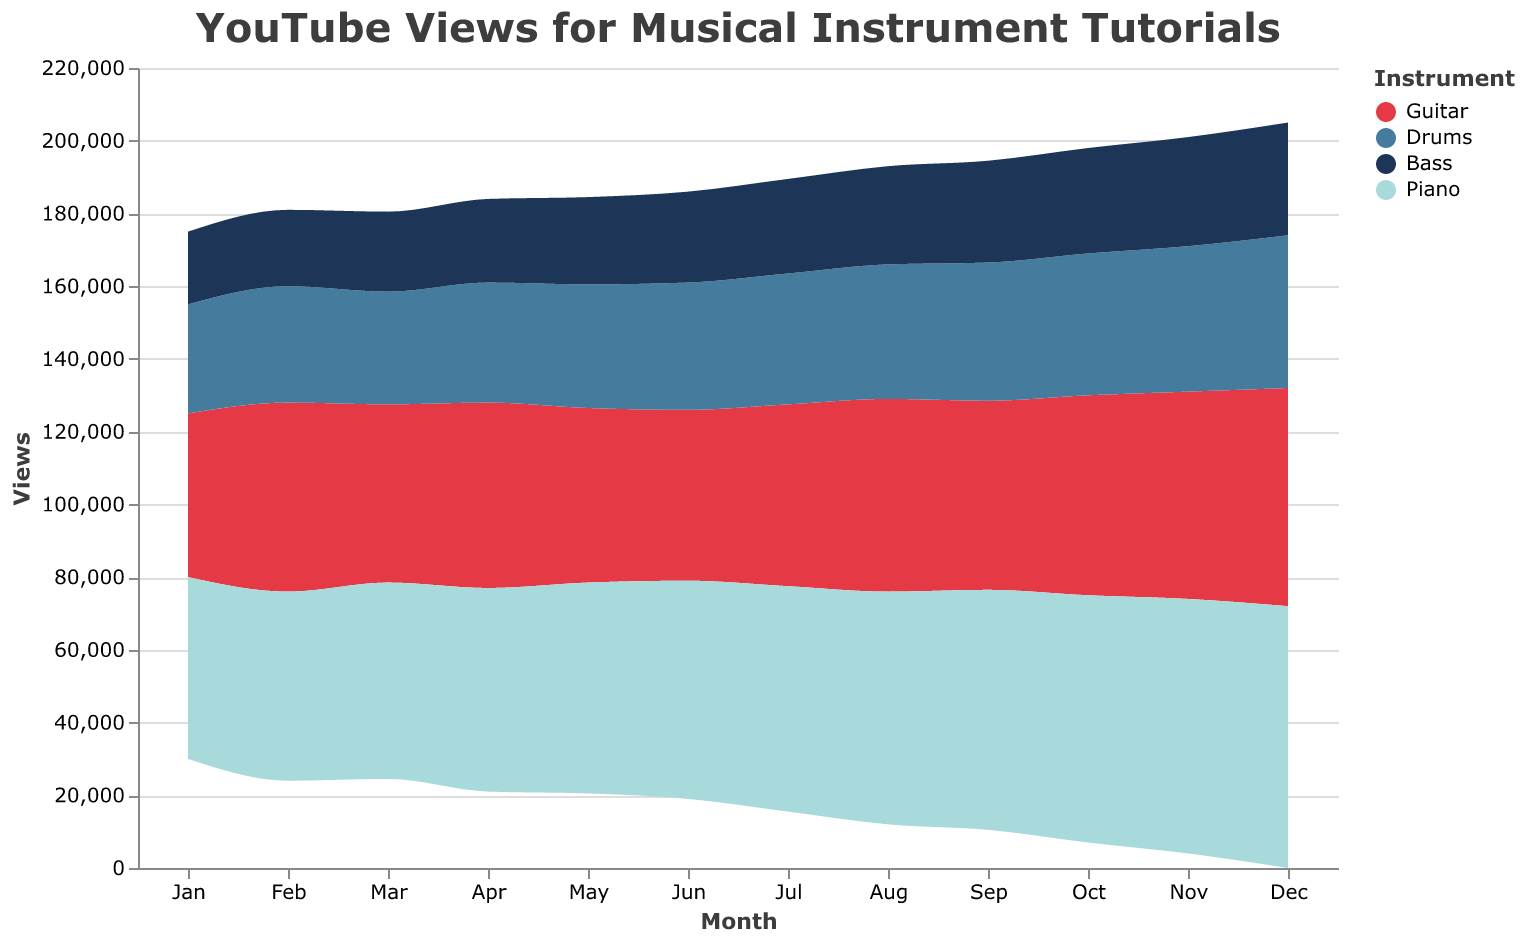What's the title of the figure? The title is usually located at the top of the figure. It provides an overview of what the chart represents. Here, it states: "YouTube Views for Musical Instrument Tutorials".
Answer: YouTube Views for Musical Instrument Tutorials What is the color used to represent Guitar in the graph? Each instrument type is represented by a distinct color. The legend indicates that Guitar is represented by a red color.
Answer: Red Which month had the highest views for Piano tutorials? Observe the area corresponding to Piano, which is represented by a light blue color. The highest peak in this area occurs in December, where the views reach 72,000.
Answer: December How do the views for Drums tutorials in April compare to those in May? Look at the area representing Drums, which is dark blue. In April, the views are 33,000 and in May, the views are 34,000. So, they increase by 1,000 views in May.
Answer: Increase by 1,000 views What is the average monthly views for Bass tutorials throughout the year? Sum up the views for each month for Bass and then divide by 12. The views are: (20000 + 21000 + 22000 + 23000 + 24000 + 25000 + 26000 + 27000 + 28000 + 29000 + 30000 + 31000) = 316000. Divide this sum by 12 to get the average. 316000 / 12 = 26333.33.
Answer: 26,333.33 Which instrument shows a consistent increase in views every month? By examining the areas, Piano (light blue area) clearly shows a consistent increase in views every month moving from January to December.
Answer: Piano In which month do Guitar tutorials see the lowest number of views? Look at the red area representing Guitar. The lowest point occurs in January with 45,000 views.
Answer: January How many more views did Piano tutorials get in June compared to Guitar tutorials? Piano views in June are 60,000 and Guitar views in June are 47,000. The difference is 60,000 - 47,000 = 13,000.
Answer: 13,000 Which instrument had the smallest increase in views from January to December? Each instrument's view increase can be calculated by subtracting January's views from December's views. For Guitar: 60000 - 45000 = 15000, Drums: 42000 - 30000 = 12000, Bass: 31000 - 20000 = 11000, Piano: 72000 - 50000 = 22000. Bass had the smallest increase, 11,000 views.
Answer: Bass 